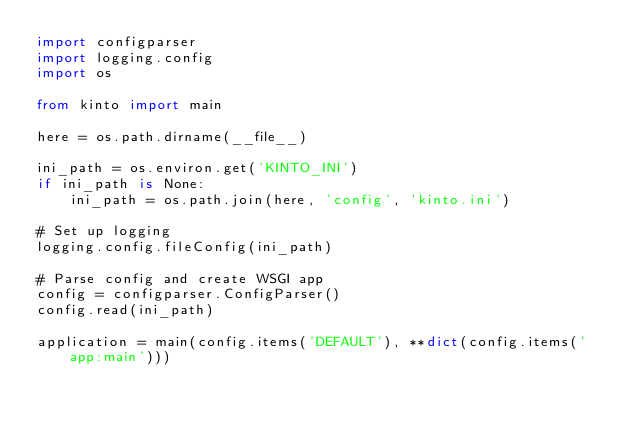Convert code to text. <code><loc_0><loc_0><loc_500><loc_500><_Python_>import configparser
import logging.config
import os

from kinto import main

here = os.path.dirname(__file__)

ini_path = os.environ.get('KINTO_INI')
if ini_path is None:
    ini_path = os.path.join(here, 'config', 'kinto.ini')

# Set up logging
logging.config.fileConfig(ini_path)

# Parse config and create WSGI app
config = configparser.ConfigParser()
config.read(ini_path)

application = main(config.items('DEFAULT'), **dict(config.items('app:main')))
</code> 